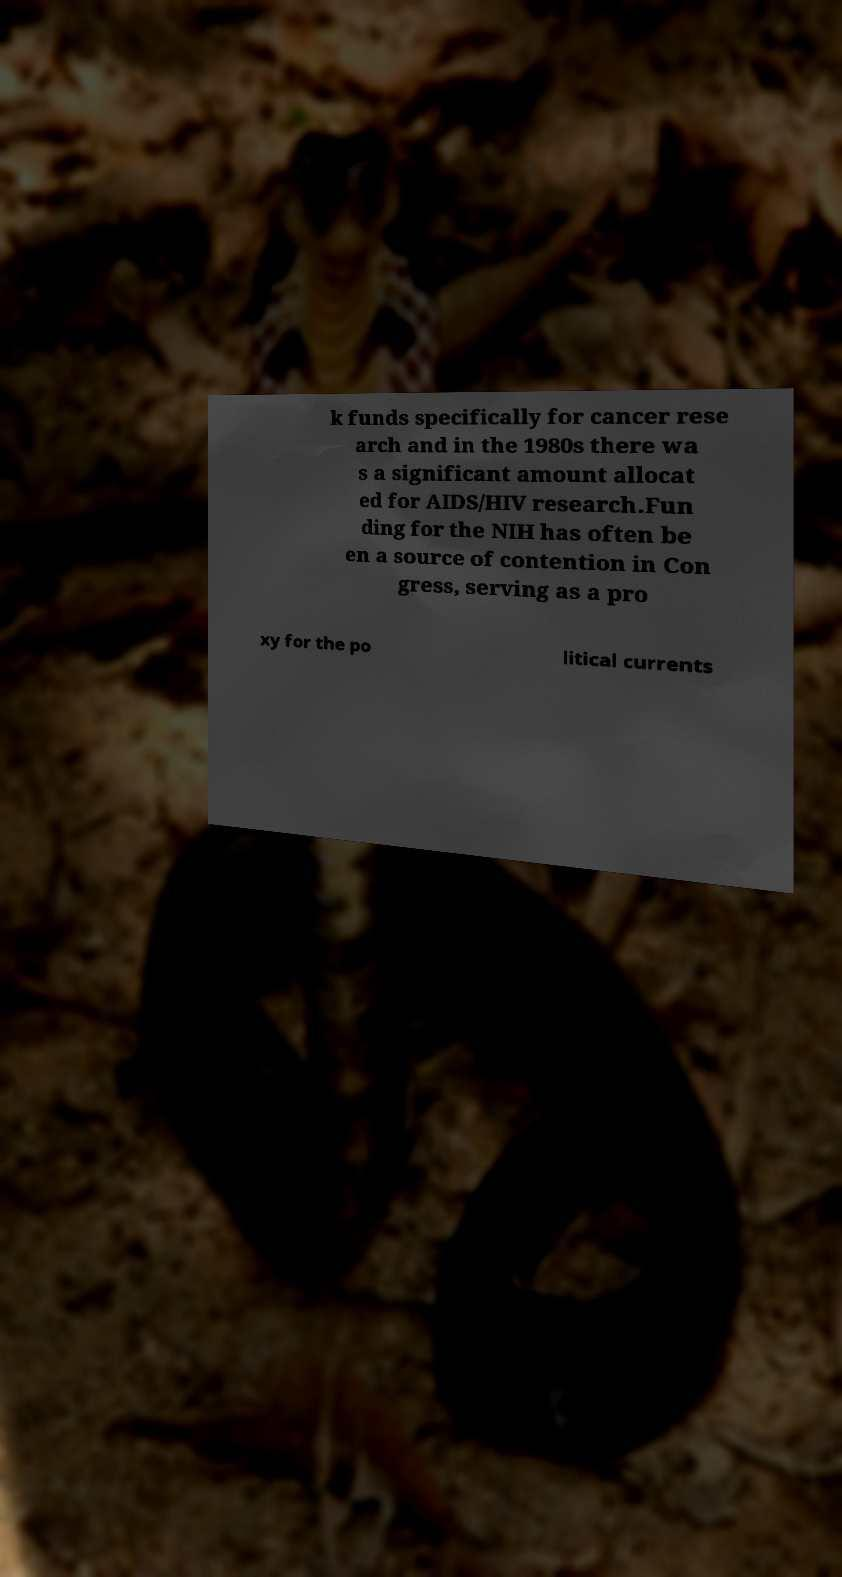Could you assist in decoding the text presented in this image and type it out clearly? k funds specifically for cancer rese arch and in the 1980s there wa s a significant amount allocat ed for AIDS/HIV research.Fun ding for the NIH has often be en a source of contention in Con gress, serving as a pro xy for the po litical currents 